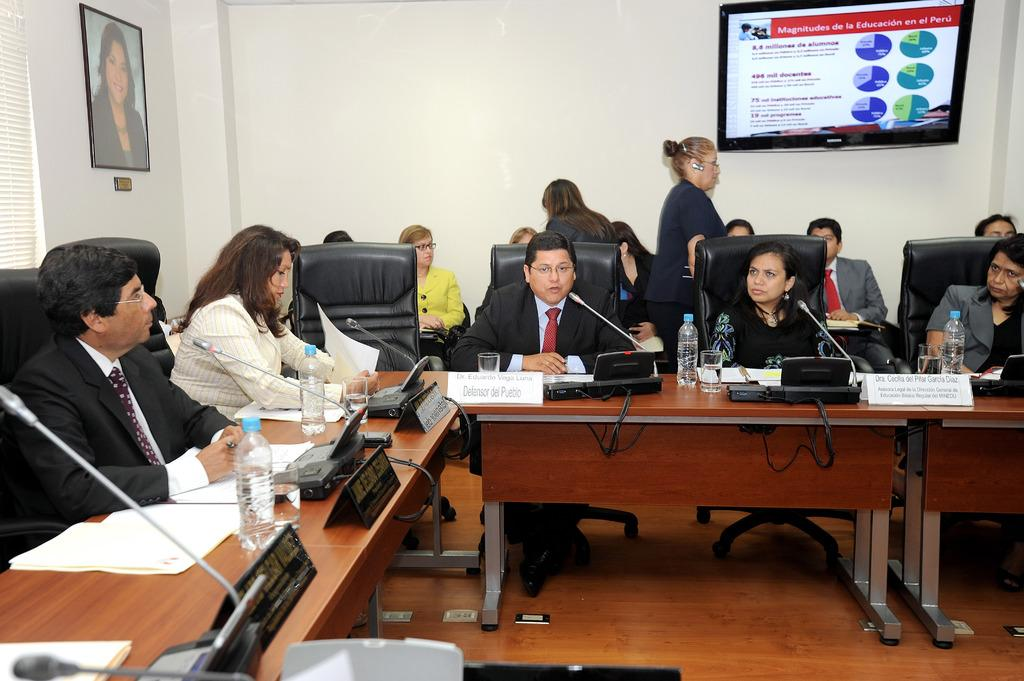Where was the image taken? The image was taken inside a conference hall. What can be seen in the image? There are several delegates in the image. What are the delegates sitting on? The delegates are sitting on black chairs. What can be seen in the background of the image? There is a photo frame and an LCD attached to the wall in the background of the image. What type of oven can be seen in the image? There is no oven present in the image. Is there an owl sitting on the shoulder of one of the delegates? No, there is no owl present in the image. 